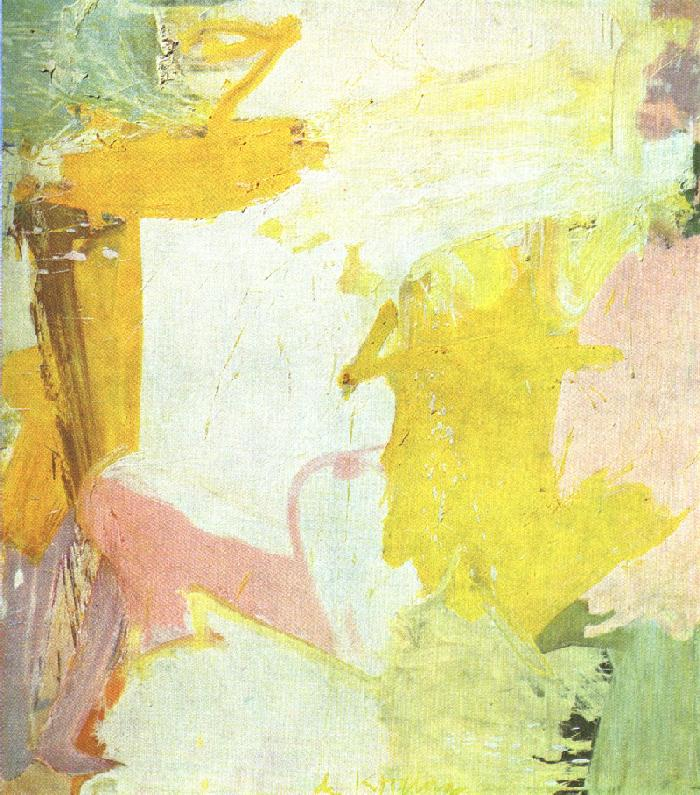If this painting could make a sound, what do you think it would be like? If this painting could make a sound, it would likely be a soft, soothing melody, akin to the gentle rustling of leaves in a light breeze or the calming tones of a distant wind chime. The sound would be delicate, with harmonious notes that blend seamlessly, mirroring the fluid and dreamy quality of the artwork. It would create an auditory experience that is equally as tranquil and serene as the visual impression, evoking a sense of peace and relaxation. 